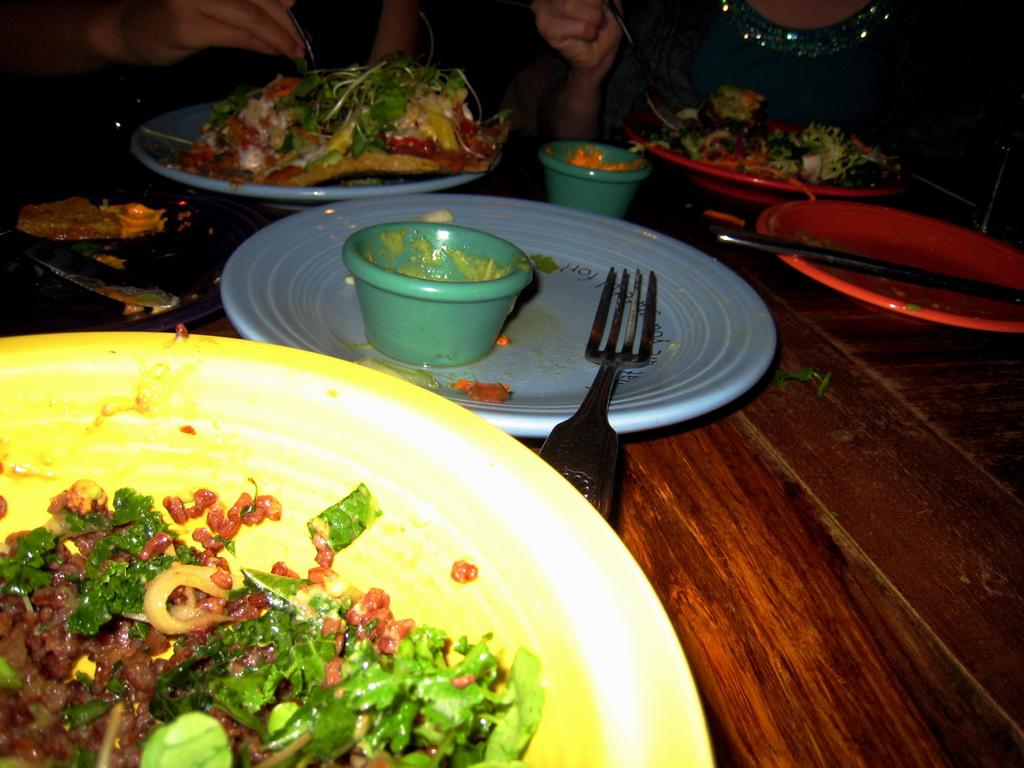What types of utensils are on the table in the image? There are forks and spoons on the table in the image. What else can be found on the table besides utensils? There are plates, cups, and food on the table. Can you describe the woman in the image? The woman is wearing a green dress and is on the right side of the image. What is the person in the top left of the image doing? The person is holding a fork. Can you tell me how many bees are buzzing around the table in the image? There are no bees present in the image. What type of drop is falling from the border of the image? There is no drop falling from the border of the image, and there is no border mentioned in the provided facts. 